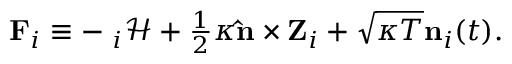<formula> <loc_0><loc_0><loc_500><loc_500>\begin{array} { r } { { F } _ { i } \equiv - { \nabla } _ { i } \mathcal { H } + \frac { 1 } { 2 } \kappa { \hat { n } } \times { Z } _ { i } + \sqrt { \kappa T } { n } _ { i } ( t ) . } \end{array}</formula> 